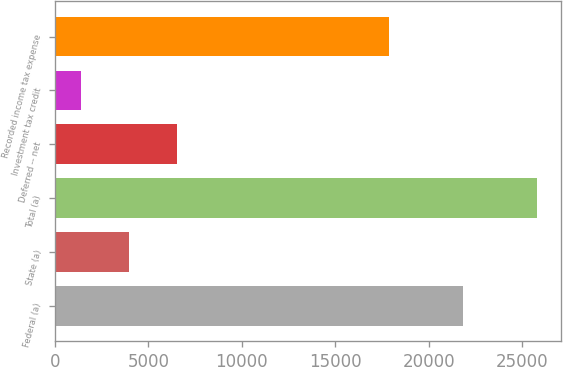<chart> <loc_0><loc_0><loc_500><loc_500><bar_chart><fcel>Federal (a)<fcel>State (a)<fcel>Total (a)<fcel>Deferred -- net<fcel>Investment tax credit<fcel>Recorded income tax expense<nl><fcel>21817<fcel>3969<fcel>25786<fcel>6529<fcel>1411<fcel>17846<nl></chart> 